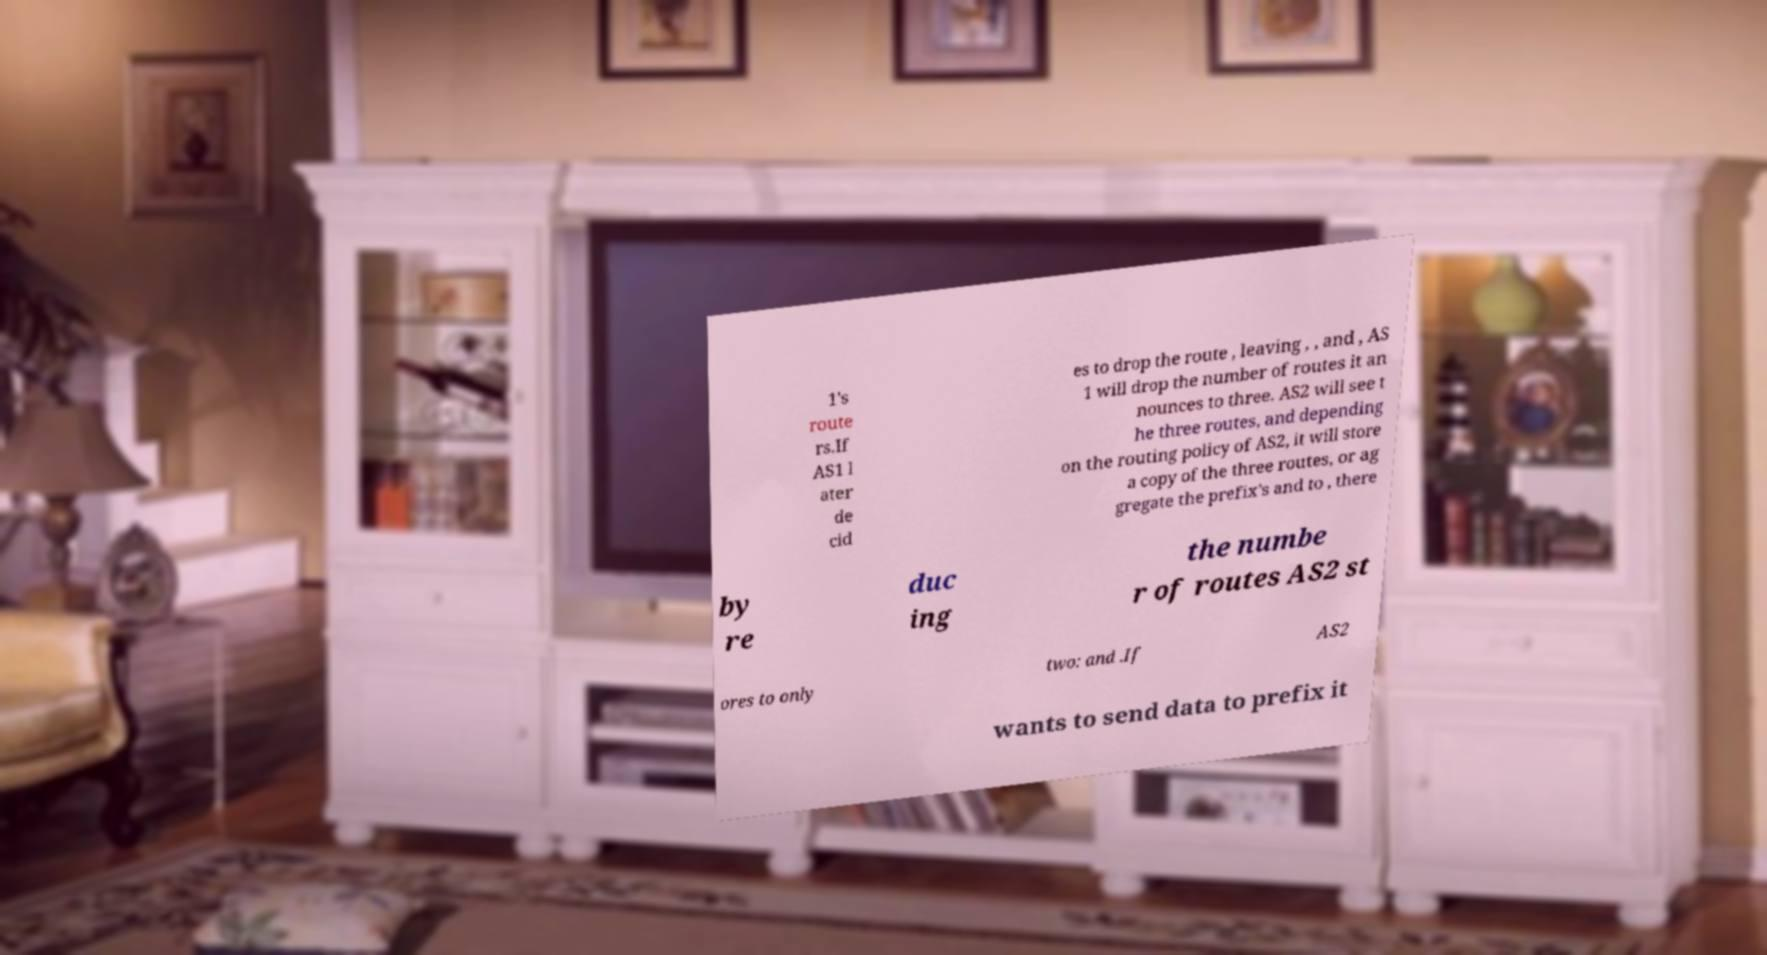Could you assist in decoding the text presented in this image and type it out clearly? 1's route rs.If AS1 l ater de cid es to drop the route , leaving , , and , AS 1 will drop the number of routes it an nounces to three. AS2 will see t he three routes, and depending on the routing policy of AS2, it will store a copy of the three routes, or ag gregate the prefix's and to , there by re duc ing the numbe r of routes AS2 st ores to only two: and .If AS2 wants to send data to prefix it 